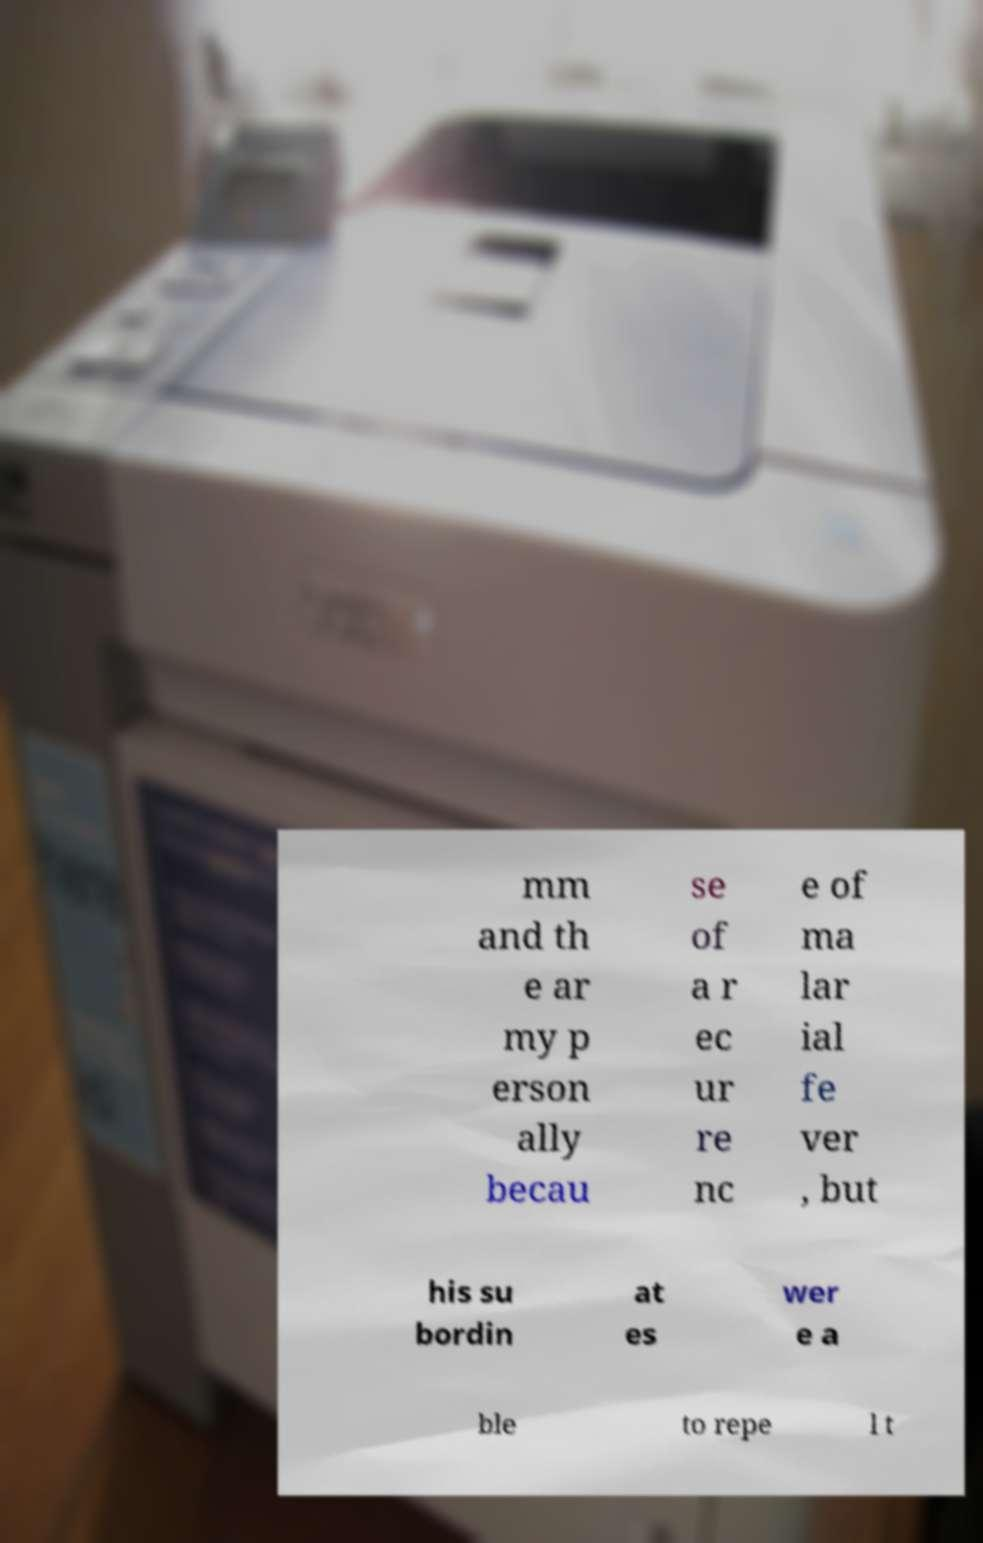For documentation purposes, I need the text within this image transcribed. Could you provide that? mm and th e ar my p erson ally becau se of a r ec ur re nc e of ma lar ial fe ver , but his su bordin at es wer e a ble to repe l t 